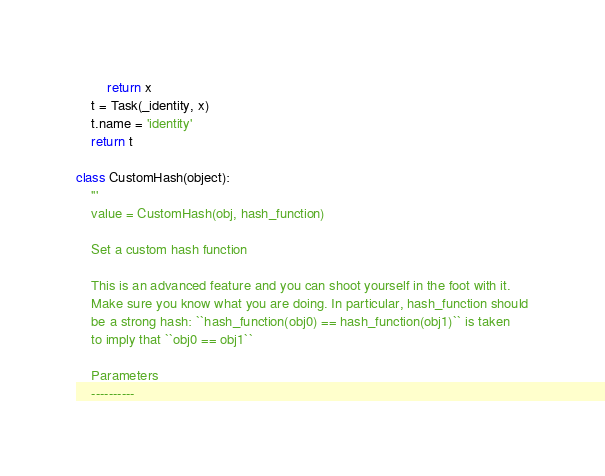<code> <loc_0><loc_0><loc_500><loc_500><_Python_>        return x
    t = Task(_identity, x)
    t.name = 'identity'
    return t

class CustomHash(object):
    '''
    value = CustomHash(obj, hash_function)

    Set a custom hash function

    This is an advanced feature and you can shoot yourself in the foot with it.
    Make sure you know what you are doing. In particular, hash_function should
    be a strong hash: ``hash_function(obj0) == hash_function(obj1)`` is taken
    to imply that ``obj0 == obj1``

    Parameters
    ----------</code> 